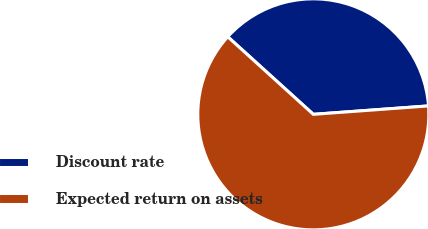Convert chart to OTSL. <chart><loc_0><loc_0><loc_500><loc_500><pie_chart><fcel>Discount rate<fcel>Expected return on assets<nl><fcel>37.12%<fcel>62.88%<nl></chart> 